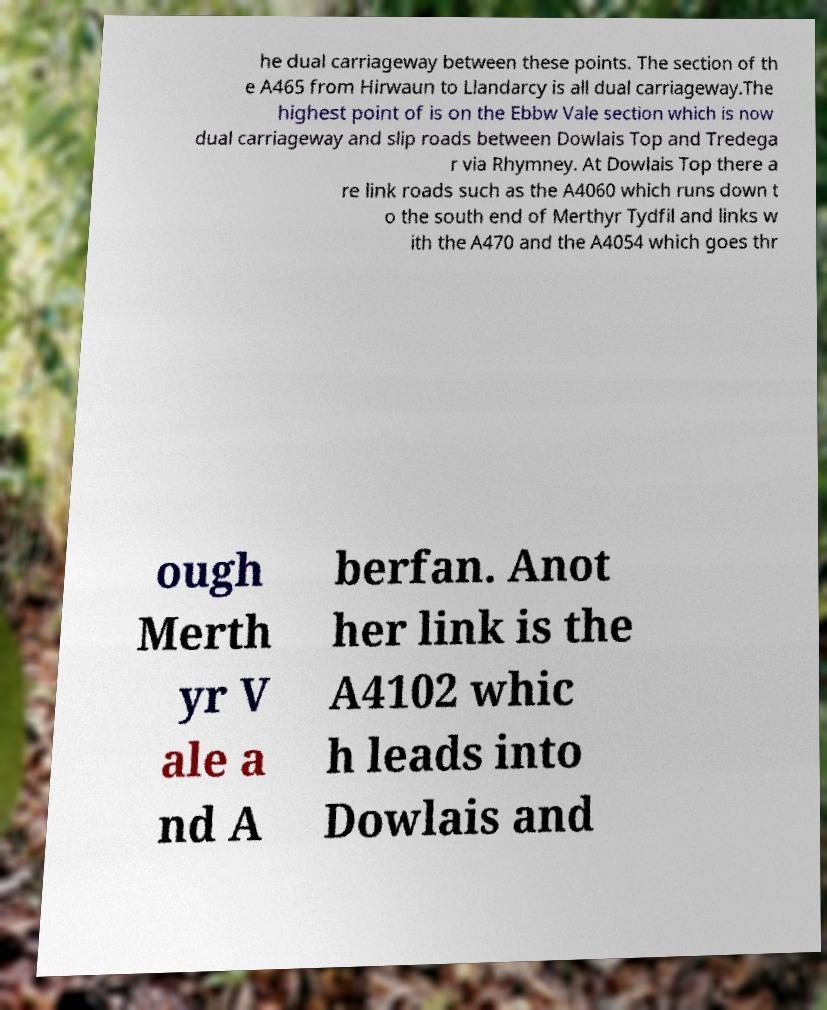I need the written content from this picture converted into text. Can you do that? he dual carriageway between these points. The section of th e A465 from Hirwaun to Llandarcy is all dual carriageway.The highest point of is on the Ebbw Vale section which is now dual carriageway and slip roads between Dowlais Top and Tredega r via Rhymney. At Dowlais Top there a re link roads such as the A4060 which runs down t o the south end of Merthyr Tydfil and links w ith the A470 and the A4054 which goes thr ough Merth yr V ale a nd A berfan. Anot her link is the A4102 whic h leads into Dowlais and 